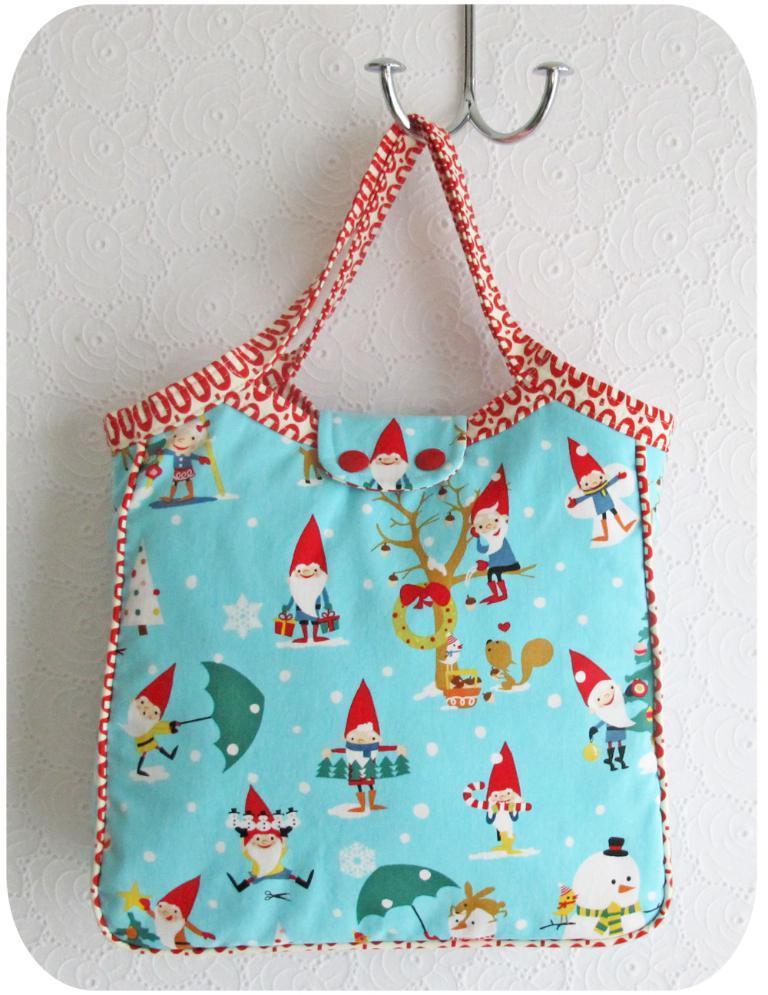Could you give a brief overview of what you see in this image? To the hanger there is a blue color bag with toys on it. 